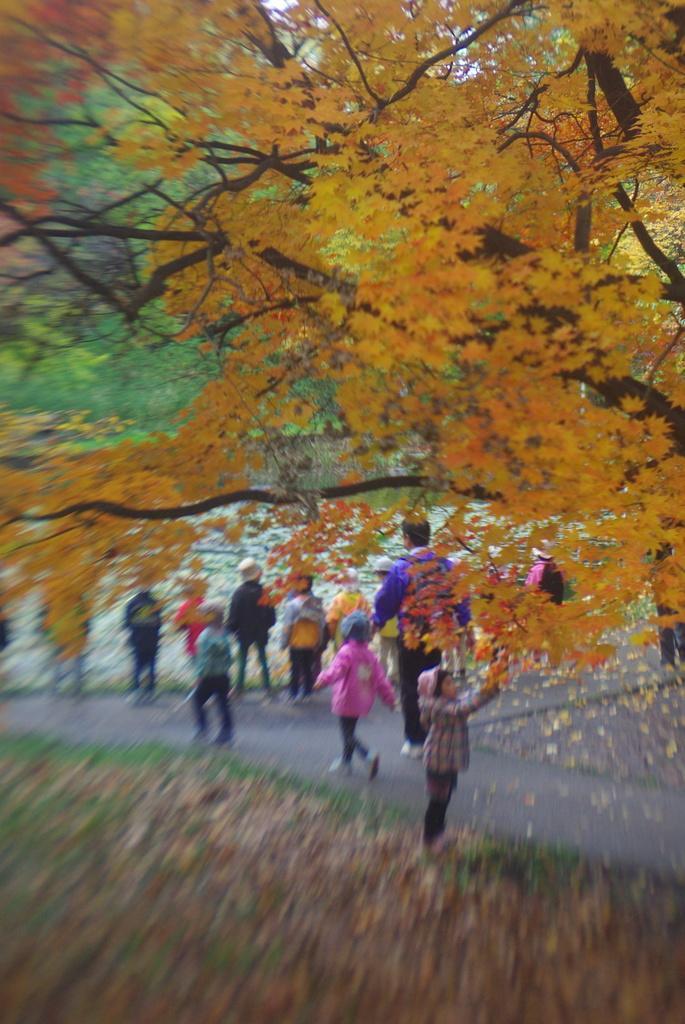Please provide a concise description of this image. In the center of the image there are children walking on the road. In the background of the image there are trees. At the bottom of the image there are dry leaves. 